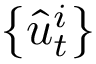Convert formula to latex. <formula><loc_0><loc_0><loc_500><loc_500>\left \{ \hat { u } _ { t } ^ { i } \right \}</formula> 